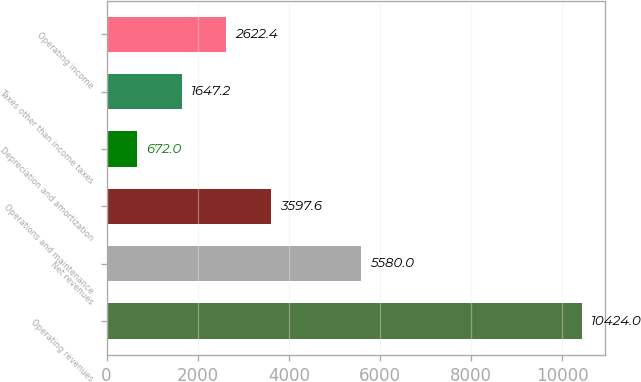Convert chart to OTSL. <chart><loc_0><loc_0><loc_500><loc_500><bar_chart><fcel>Operating revenues<fcel>Net revenues<fcel>Operations and maintenance<fcel>Depreciation and amortization<fcel>Taxes other than income taxes<fcel>Operating income<nl><fcel>10424<fcel>5580<fcel>3597.6<fcel>672<fcel>1647.2<fcel>2622.4<nl></chart> 